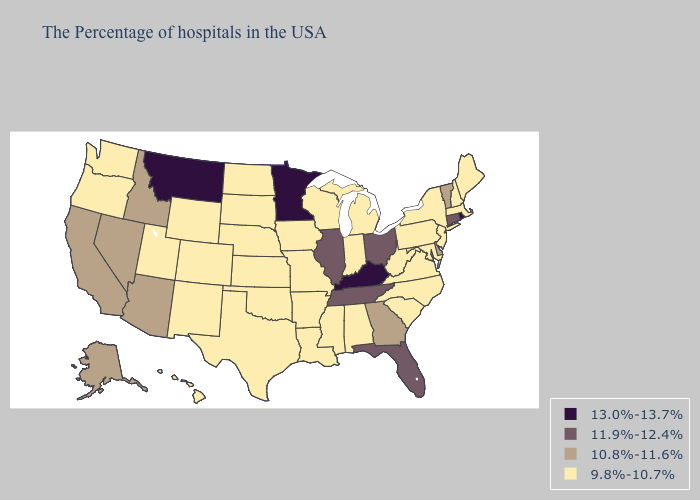Does Idaho have the lowest value in the USA?
Write a very short answer. No. What is the value of Wisconsin?
Write a very short answer. 9.8%-10.7%. Does Alabama have the lowest value in the South?
Quick response, please. Yes. Which states have the lowest value in the USA?
Concise answer only. Maine, Massachusetts, New Hampshire, New York, New Jersey, Maryland, Pennsylvania, Virginia, North Carolina, South Carolina, West Virginia, Michigan, Indiana, Alabama, Wisconsin, Mississippi, Louisiana, Missouri, Arkansas, Iowa, Kansas, Nebraska, Oklahoma, Texas, South Dakota, North Dakota, Wyoming, Colorado, New Mexico, Utah, Washington, Oregon, Hawaii. What is the value of Washington?
Concise answer only. 9.8%-10.7%. What is the highest value in the USA?
Write a very short answer. 13.0%-13.7%. What is the highest value in the West ?
Keep it brief. 13.0%-13.7%. Among the states that border North Dakota , which have the lowest value?
Quick response, please. South Dakota. Which states have the lowest value in the Northeast?
Write a very short answer. Maine, Massachusetts, New Hampshire, New York, New Jersey, Pennsylvania. Name the states that have a value in the range 9.8%-10.7%?
Be succinct. Maine, Massachusetts, New Hampshire, New York, New Jersey, Maryland, Pennsylvania, Virginia, North Carolina, South Carolina, West Virginia, Michigan, Indiana, Alabama, Wisconsin, Mississippi, Louisiana, Missouri, Arkansas, Iowa, Kansas, Nebraska, Oklahoma, Texas, South Dakota, North Dakota, Wyoming, Colorado, New Mexico, Utah, Washington, Oregon, Hawaii. Name the states that have a value in the range 10.8%-11.6%?
Short answer required. Vermont, Delaware, Georgia, Arizona, Idaho, Nevada, California, Alaska. Name the states that have a value in the range 9.8%-10.7%?
Keep it brief. Maine, Massachusetts, New Hampshire, New York, New Jersey, Maryland, Pennsylvania, Virginia, North Carolina, South Carolina, West Virginia, Michigan, Indiana, Alabama, Wisconsin, Mississippi, Louisiana, Missouri, Arkansas, Iowa, Kansas, Nebraska, Oklahoma, Texas, South Dakota, North Dakota, Wyoming, Colorado, New Mexico, Utah, Washington, Oregon, Hawaii. What is the value of Oregon?
Write a very short answer. 9.8%-10.7%. Name the states that have a value in the range 10.8%-11.6%?
Concise answer only. Vermont, Delaware, Georgia, Arizona, Idaho, Nevada, California, Alaska. 